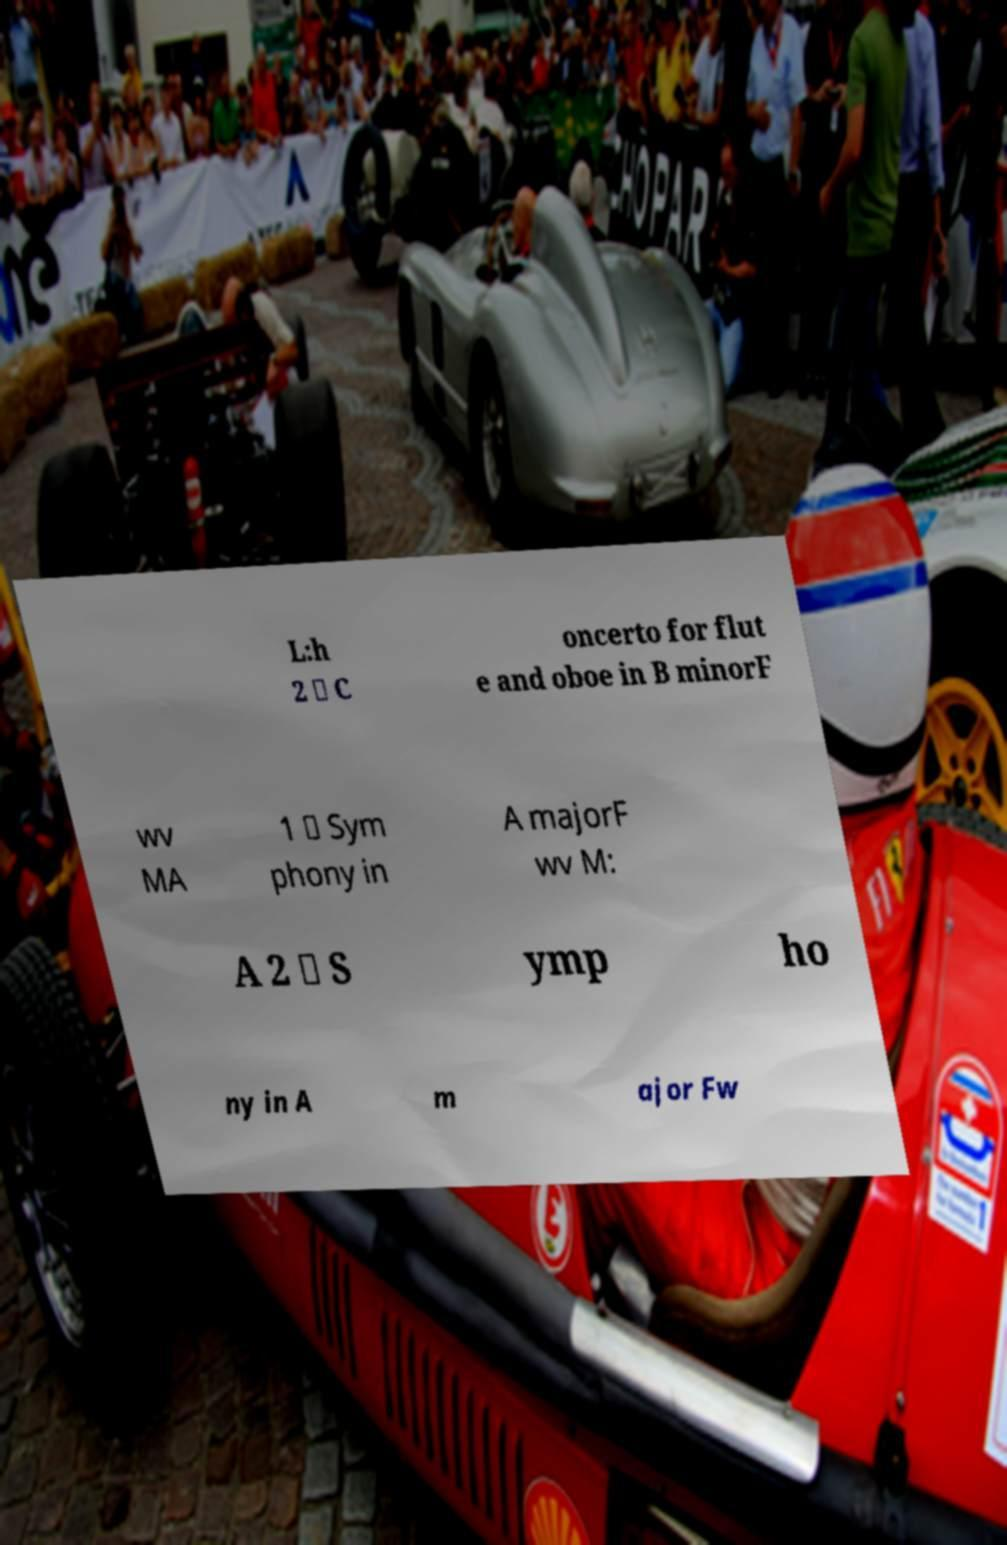Could you extract and type out the text from this image? L:h 2 \ C oncerto for flut e and oboe in B minorF wv MA 1 \ Sym phony in A majorF wv M: A 2 \ S ymp ho ny in A m ajor Fw 